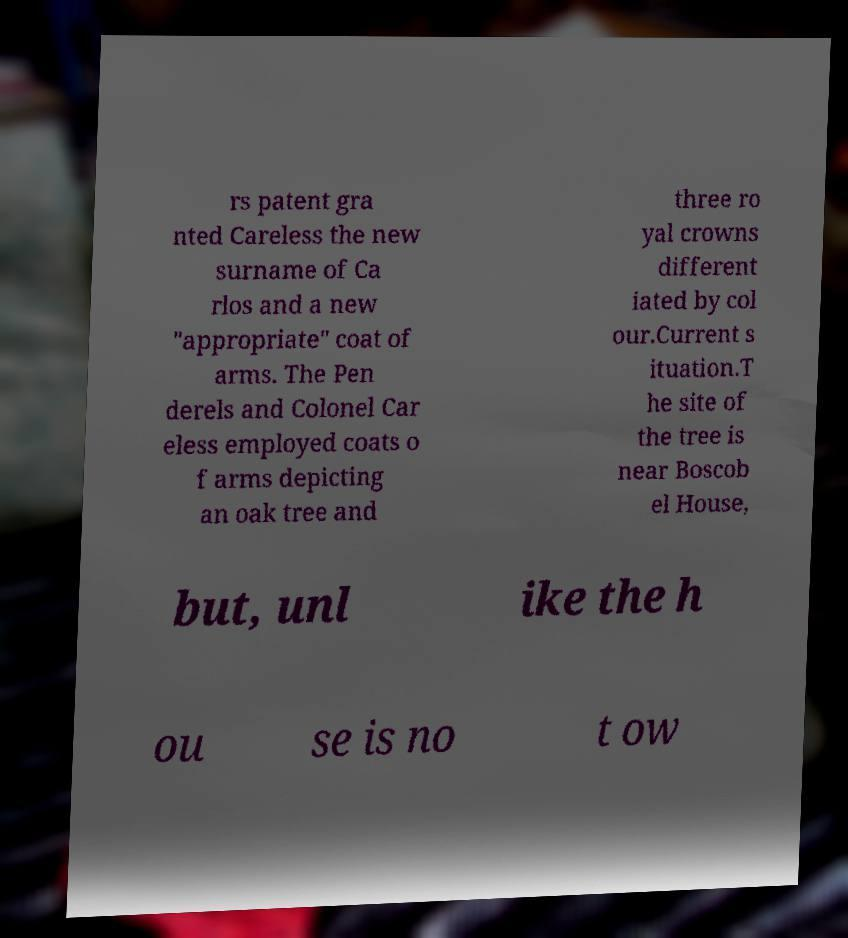Can you accurately transcribe the text from the provided image for me? rs patent gra nted Careless the new surname of Ca rlos and a new "appropriate" coat of arms. The Pen derels and Colonel Car eless employed coats o f arms depicting an oak tree and three ro yal crowns different iated by col our.Current s ituation.T he site of the tree is near Boscob el House, but, unl ike the h ou se is no t ow 